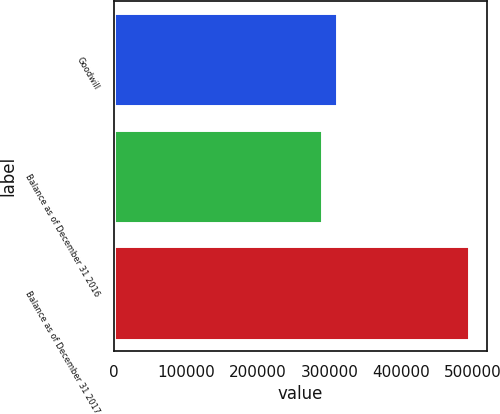<chart> <loc_0><loc_0><loc_500><loc_500><bar_chart><fcel>Goodwill<fcel>Balance as of December 31 2016<fcel>Balance as of December 31 2017<nl><fcel>310492<fcel>290041<fcel>494548<nl></chart> 